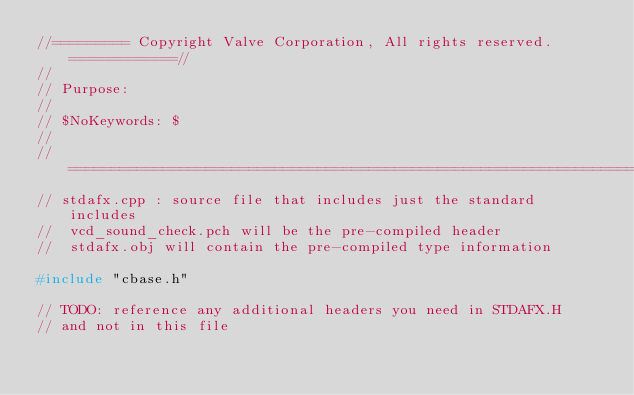Convert code to text. <code><loc_0><loc_0><loc_500><loc_500><_C++_>//========= Copyright Valve Corporation, All rights reserved. ============//
//
// Purpose: 
//
// $NoKeywords: $
//
//=============================================================================//
// stdafx.cpp : source file that includes just the standard includes
//	vcd_sound_check.pch will be the pre-compiled header
//	stdafx.obj will contain the pre-compiled type information

#include "cbase.h"

// TODO: reference any additional headers you need in STDAFX.H
// and not in this file
</code> 